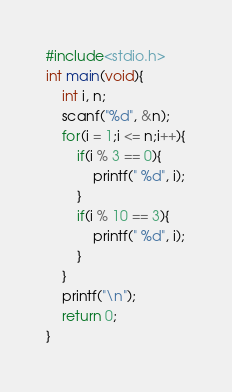<code> <loc_0><loc_0><loc_500><loc_500><_C_>#include<stdio.h>
int main(void){
	int i, n;
	scanf("%d", &n);
	for(i = 1;i <= n;i++){
		if(i % 3 == 0){
			printf(" %d", i);
		}
		if(i % 10 == 3){
			printf(" %d", i);
		}
	}
	printf("\n");
	return 0;
}</code> 